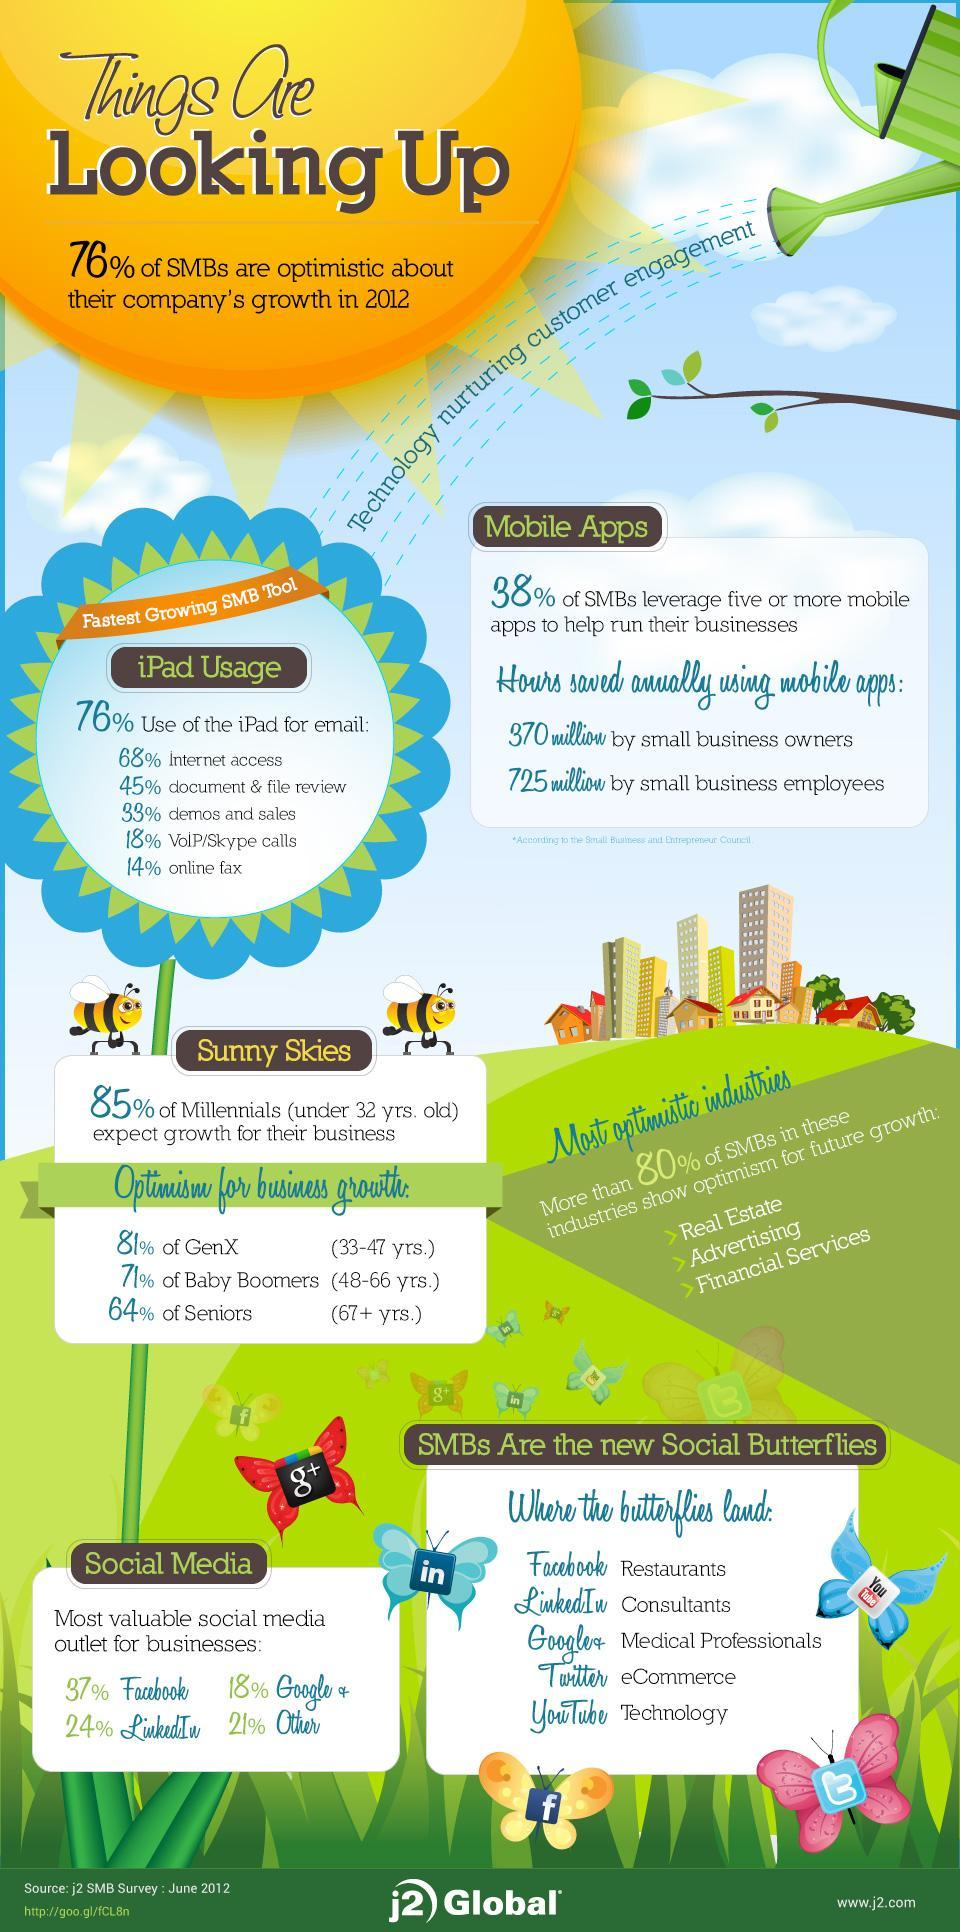What percentage of SMB's use Linkedin more than other social media tools?
Answer the question with a short phrase. 3% What percentage of SMB's use Facebook than Google + for their business? 19% 